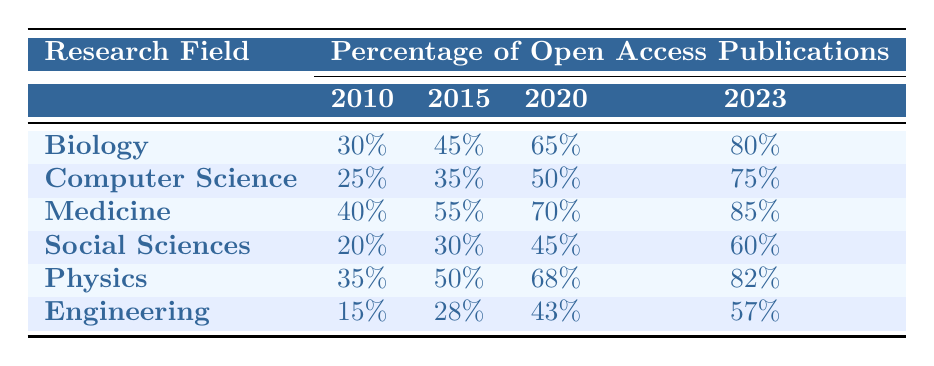What was the percentage of open access publications in Biology in 2010? According to the table, the value listed under the Biology row for the year 2010 is 30%.
Answer: 30% What research field had the highest percentage of open access publications in 2023? The table shows that in 2023, Medicine had the highest percentage of open access publications at 85%.
Answer: Medicine What is the percentage increase in open access publications from 2010 to 2023 in Computer Science? The percentage of open access publications in Computer Science increased from 25% in 2010 to 75% in 2023. This is a difference of 75% - 25% = 50%.
Answer: 50% Did Social Sciences have more open access publications than Engineering in 2023? The table shows that Social Sciences had 60% open access publications in 2023, while Engineering had only 57%. Therefore, Social Sciences had more open access publications.
Answer: Yes What was the average percentage of open access publications across all fields in 2020? The percentages of open access publications in 2020 are: Biology (65%), Computer Science (50%), Medicine (70%), Social Sciences (45%), Physics (68%), Engineering (43%). Summing these gives 65 + 50 + 70 + 45 + 68 + 43 = 341. Dividing by 6 gives an average of 341 / 6 = 56.83%.
Answer: 56.83% Which field saw the smallest percentage increase in open access publications from 2010 to 2023? To find this, we need to calculate the increase for each field: Biology (50%), Computer Science (50%), Medicine (45%), Social Sciences (40%), Physics (47%), and Engineering (42%). The smallest increase is 40% for Social Sciences.
Answer: Social Sciences Was the percentage of open access publications in Physics higher than 70% in 2020? According to the table, the percentage for Physics in 2020 is 68%, which is less than 70%.
Answer: No Which two fields had a percentage of open access publications greater than 70% in 2023? The table indicates that in 2023, Medicine (85%) and Biology (80%) had percentages greater than 70%.
Answer: Medicine and Biology 